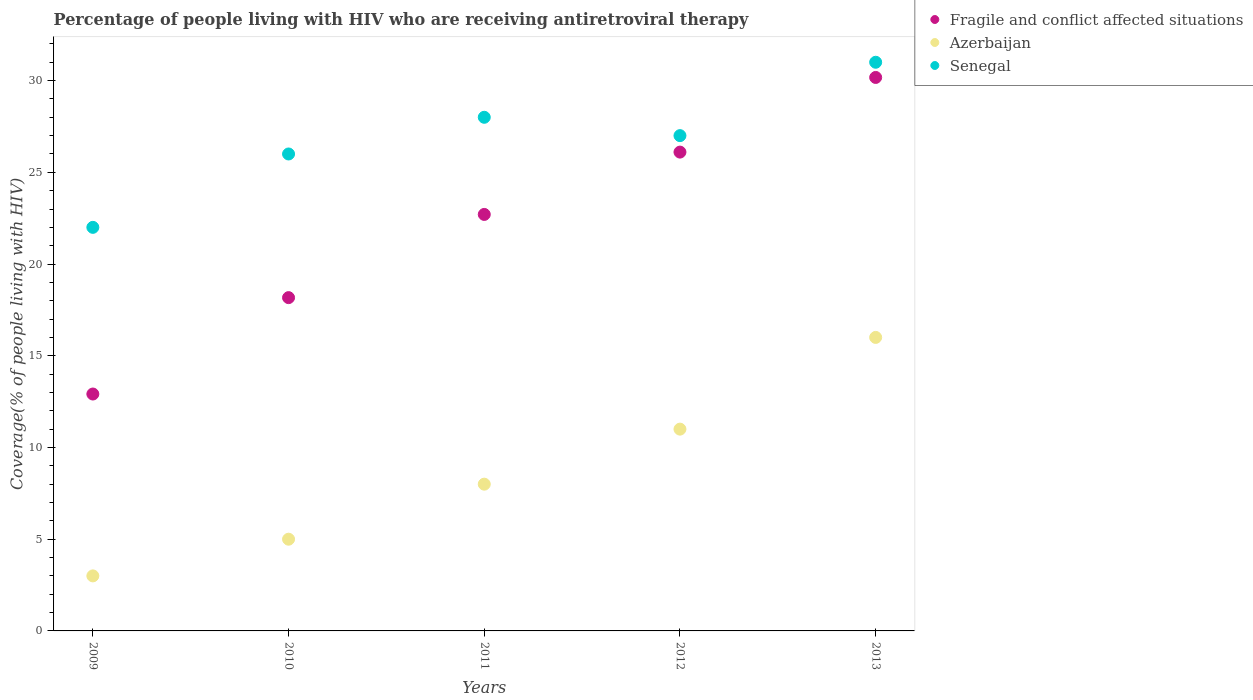How many different coloured dotlines are there?
Ensure brevity in your answer.  3. Is the number of dotlines equal to the number of legend labels?
Keep it short and to the point. Yes. What is the percentage of the HIV infected people who are receiving antiretroviral therapy in Fragile and conflict affected situations in 2012?
Give a very brief answer. 26.1. Across all years, what is the maximum percentage of the HIV infected people who are receiving antiretroviral therapy in Senegal?
Give a very brief answer. 31. Across all years, what is the minimum percentage of the HIV infected people who are receiving antiretroviral therapy in Azerbaijan?
Provide a succinct answer. 3. What is the total percentage of the HIV infected people who are receiving antiretroviral therapy in Azerbaijan in the graph?
Your answer should be compact. 43. What is the difference between the percentage of the HIV infected people who are receiving antiretroviral therapy in Azerbaijan in 2009 and that in 2013?
Offer a very short reply. -13. What is the difference between the percentage of the HIV infected people who are receiving antiretroviral therapy in Azerbaijan in 2013 and the percentage of the HIV infected people who are receiving antiretroviral therapy in Fragile and conflict affected situations in 2012?
Ensure brevity in your answer.  -10.1. What is the average percentage of the HIV infected people who are receiving antiretroviral therapy in Fragile and conflict affected situations per year?
Your answer should be very brief. 22.01. In the year 2010, what is the difference between the percentage of the HIV infected people who are receiving antiretroviral therapy in Azerbaijan and percentage of the HIV infected people who are receiving antiretroviral therapy in Senegal?
Provide a short and direct response. -21. In how many years, is the percentage of the HIV infected people who are receiving antiretroviral therapy in Azerbaijan greater than 18 %?
Provide a short and direct response. 0. What is the ratio of the percentage of the HIV infected people who are receiving antiretroviral therapy in Azerbaijan in 2009 to that in 2011?
Your answer should be compact. 0.38. What is the difference between the highest and the second highest percentage of the HIV infected people who are receiving antiretroviral therapy in Fragile and conflict affected situations?
Provide a succinct answer. 4.07. What is the difference between the highest and the lowest percentage of the HIV infected people who are receiving antiretroviral therapy in Fragile and conflict affected situations?
Make the answer very short. 17.26. Is the sum of the percentage of the HIV infected people who are receiving antiretroviral therapy in Fragile and conflict affected situations in 2009 and 2011 greater than the maximum percentage of the HIV infected people who are receiving antiretroviral therapy in Senegal across all years?
Offer a very short reply. Yes. Is it the case that in every year, the sum of the percentage of the HIV infected people who are receiving antiretroviral therapy in Fragile and conflict affected situations and percentage of the HIV infected people who are receiving antiretroviral therapy in Senegal  is greater than the percentage of the HIV infected people who are receiving antiretroviral therapy in Azerbaijan?
Offer a terse response. Yes. What is the difference between two consecutive major ticks on the Y-axis?
Ensure brevity in your answer.  5. Does the graph contain grids?
Your answer should be very brief. No. How are the legend labels stacked?
Make the answer very short. Vertical. What is the title of the graph?
Your response must be concise. Percentage of people living with HIV who are receiving antiretroviral therapy. What is the label or title of the X-axis?
Make the answer very short. Years. What is the label or title of the Y-axis?
Your response must be concise. Coverage(% of people living with HIV). What is the Coverage(% of people living with HIV) in Fragile and conflict affected situations in 2009?
Give a very brief answer. 12.91. What is the Coverage(% of people living with HIV) in Fragile and conflict affected situations in 2010?
Ensure brevity in your answer.  18.17. What is the Coverage(% of people living with HIV) of Azerbaijan in 2010?
Provide a succinct answer. 5. What is the Coverage(% of people living with HIV) in Senegal in 2010?
Give a very brief answer. 26. What is the Coverage(% of people living with HIV) in Fragile and conflict affected situations in 2011?
Ensure brevity in your answer.  22.7. What is the Coverage(% of people living with HIV) of Senegal in 2011?
Provide a short and direct response. 28. What is the Coverage(% of people living with HIV) of Fragile and conflict affected situations in 2012?
Give a very brief answer. 26.1. What is the Coverage(% of people living with HIV) of Fragile and conflict affected situations in 2013?
Keep it short and to the point. 30.17. What is the Coverage(% of people living with HIV) of Azerbaijan in 2013?
Provide a succinct answer. 16. Across all years, what is the maximum Coverage(% of people living with HIV) in Fragile and conflict affected situations?
Offer a terse response. 30.17. Across all years, what is the maximum Coverage(% of people living with HIV) in Azerbaijan?
Provide a succinct answer. 16. Across all years, what is the minimum Coverage(% of people living with HIV) in Fragile and conflict affected situations?
Your answer should be very brief. 12.91. What is the total Coverage(% of people living with HIV) in Fragile and conflict affected situations in the graph?
Your answer should be very brief. 110.06. What is the total Coverage(% of people living with HIV) of Senegal in the graph?
Your answer should be compact. 134. What is the difference between the Coverage(% of people living with HIV) in Fragile and conflict affected situations in 2009 and that in 2010?
Give a very brief answer. -5.25. What is the difference between the Coverage(% of people living with HIV) of Azerbaijan in 2009 and that in 2010?
Make the answer very short. -2. What is the difference between the Coverage(% of people living with HIV) of Fragile and conflict affected situations in 2009 and that in 2011?
Provide a short and direct response. -9.79. What is the difference between the Coverage(% of people living with HIV) in Azerbaijan in 2009 and that in 2011?
Ensure brevity in your answer.  -5. What is the difference between the Coverage(% of people living with HIV) in Fragile and conflict affected situations in 2009 and that in 2012?
Your answer should be compact. -13.19. What is the difference between the Coverage(% of people living with HIV) of Senegal in 2009 and that in 2012?
Make the answer very short. -5. What is the difference between the Coverage(% of people living with HIV) of Fragile and conflict affected situations in 2009 and that in 2013?
Offer a terse response. -17.26. What is the difference between the Coverage(% of people living with HIV) of Fragile and conflict affected situations in 2010 and that in 2011?
Offer a terse response. -4.54. What is the difference between the Coverage(% of people living with HIV) of Azerbaijan in 2010 and that in 2011?
Your answer should be very brief. -3. What is the difference between the Coverage(% of people living with HIV) of Senegal in 2010 and that in 2011?
Offer a very short reply. -2. What is the difference between the Coverage(% of people living with HIV) in Fragile and conflict affected situations in 2010 and that in 2012?
Provide a succinct answer. -7.93. What is the difference between the Coverage(% of people living with HIV) of Fragile and conflict affected situations in 2010 and that in 2013?
Provide a short and direct response. -12. What is the difference between the Coverage(% of people living with HIV) in Azerbaijan in 2010 and that in 2013?
Make the answer very short. -11. What is the difference between the Coverage(% of people living with HIV) of Fragile and conflict affected situations in 2011 and that in 2012?
Give a very brief answer. -3.4. What is the difference between the Coverage(% of people living with HIV) of Azerbaijan in 2011 and that in 2012?
Offer a terse response. -3. What is the difference between the Coverage(% of people living with HIV) of Senegal in 2011 and that in 2012?
Make the answer very short. 1. What is the difference between the Coverage(% of people living with HIV) in Fragile and conflict affected situations in 2011 and that in 2013?
Your answer should be compact. -7.47. What is the difference between the Coverage(% of people living with HIV) in Fragile and conflict affected situations in 2012 and that in 2013?
Offer a very short reply. -4.07. What is the difference between the Coverage(% of people living with HIV) of Azerbaijan in 2012 and that in 2013?
Your answer should be very brief. -5. What is the difference between the Coverage(% of people living with HIV) of Senegal in 2012 and that in 2013?
Offer a terse response. -4. What is the difference between the Coverage(% of people living with HIV) in Fragile and conflict affected situations in 2009 and the Coverage(% of people living with HIV) in Azerbaijan in 2010?
Provide a succinct answer. 7.91. What is the difference between the Coverage(% of people living with HIV) of Fragile and conflict affected situations in 2009 and the Coverage(% of people living with HIV) of Senegal in 2010?
Your answer should be very brief. -13.09. What is the difference between the Coverage(% of people living with HIV) of Fragile and conflict affected situations in 2009 and the Coverage(% of people living with HIV) of Azerbaijan in 2011?
Your answer should be very brief. 4.91. What is the difference between the Coverage(% of people living with HIV) in Fragile and conflict affected situations in 2009 and the Coverage(% of people living with HIV) in Senegal in 2011?
Keep it short and to the point. -15.09. What is the difference between the Coverage(% of people living with HIV) of Azerbaijan in 2009 and the Coverage(% of people living with HIV) of Senegal in 2011?
Your answer should be compact. -25. What is the difference between the Coverage(% of people living with HIV) of Fragile and conflict affected situations in 2009 and the Coverage(% of people living with HIV) of Azerbaijan in 2012?
Make the answer very short. 1.91. What is the difference between the Coverage(% of people living with HIV) of Fragile and conflict affected situations in 2009 and the Coverage(% of people living with HIV) of Senegal in 2012?
Keep it short and to the point. -14.09. What is the difference between the Coverage(% of people living with HIV) in Fragile and conflict affected situations in 2009 and the Coverage(% of people living with HIV) in Azerbaijan in 2013?
Give a very brief answer. -3.09. What is the difference between the Coverage(% of people living with HIV) of Fragile and conflict affected situations in 2009 and the Coverage(% of people living with HIV) of Senegal in 2013?
Keep it short and to the point. -18.09. What is the difference between the Coverage(% of people living with HIV) of Azerbaijan in 2009 and the Coverage(% of people living with HIV) of Senegal in 2013?
Your response must be concise. -28. What is the difference between the Coverage(% of people living with HIV) of Fragile and conflict affected situations in 2010 and the Coverage(% of people living with HIV) of Azerbaijan in 2011?
Make the answer very short. 10.17. What is the difference between the Coverage(% of people living with HIV) in Fragile and conflict affected situations in 2010 and the Coverage(% of people living with HIV) in Senegal in 2011?
Your answer should be very brief. -9.83. What is the difference between the Coverage(% of people living with HIV) in Fragile and conflict affected situations in 2010 and the Coverage(% of people living with HIV) in Azerbaijan in 2012?
Your answer should be very brief. 7.17. What is the difference between the Coverage(% of people living with HIV) of Fragile and conflict affected situations in 2010 and the Coverage(% of people living with HIV) of Senegal in 2012?
Make the answer very short. -8.83. What is the difference between the Coverage(% of people living with HIV) in Azerbaijan in 2010 and the Coverage(% of people living with HIV) in Senegal in 2012?
Provide a short and direct response. -22. What is the difference between the Coverage(% of people living with HIV) in Fragile and conflict affected situations in 2010 and the Coverage(% of people living with HIV) in Azerbaijan in 2013?
Provide a succinct answer. 2.17. What is the difference between the Coverage(% of people living with HIV) in Fragile and conflict affected situations in 2010 and the Coverage(% of people living with HIV) in Senegal in 2013?
Offer a terse response. -12.83. What is the difference between the Coverage(% of people living with HIV) in Azerbaijan in 2010 and the Coverage(% of people living with HIV) in Senegal in 2013?
Give a very brief answer. -26. What is the difference between the Coverage(% of people living with HIV) of Fragile and conflict affected situations in 2011 and the Coverage(% of people living with HIV) of Azerbaijan in 2012?
Keep it short and to the point. 11.7. What is the difference between the Coverage(% of people living with HIV) in Fragile and conflict affected situations in 2011 and the Coverage(% of people living with HIV) in Senegal in 2012?
Make the answer very short. -4.3. What is the difference between the Coverage(% of people living with HIV) in Azerbaijan in 2011 and the Coverage(% of people living with HIV) in Senegal in 2012?
Provide a succinct answer. -19. What is the difference between the Coverage(% of people living with HIV) in Fragile and conflict affected situations in 2011 and the Coverage(% of people living with HIV) in Azerbaijan in 2013?
Ensure brevity in your answer.  6.7. What is the difference between the Coverage(% of people living with HIV) in Fragile and conflict affected situations in 2011 and the Coverage(% of people living with HIV) in Senegal in 2013?
Ensure brevity in your answer.  -8.3. What is the difference between the Coverage(% of people living with HIV) of Fragile and conflict affected situations in 2012 and the Coverage(% of people living with HIV) of Azerbaijan in 2013?
Your answer should be very brief. 10.1. What is the difference between the Coverage(% of people living with HIV) of Fragile and conflict affected situations in 2012 and the Coverage(% of people living with HIV) of Senegal in 2013?
Your response must be concise. -4.9. What is the difference between the Coverage(% of people living with HIV) in Azerbaijan in 2012 and the Coverage(% of people living with HIV) in Senegal in 2013?
Ensure brevity in your answer.  -20. What is the average Coverage(% of people living with HIV) of Fragile and conflict affected situations per year?
Give a very brief answer. 22.01. What is the average Coverage(% of people living with HIV) of Senegal per year?
Your answer should be very brief. 26.8. In the year 2009, what is the difference between the Coverage(% of people living with HIV) in Fragile and conflict affected situations and Coverage(% of people living with HIV) in Azerbaijan?
Keep it short and to the point. 9.91. In the year 2009, what is the difference between the Coverage(% of people living with HIV) of Fragile and conflict affected situations and Coverage(% of people living with HIV) of Senegal?
Your response must be concise. -9.09. In the year 2009, what is the difference between the Coverage(% of people living with HIV) of Azerbaijan and Coverage(% of people living with HIV) of Senegal?
Your response must be concise. -19. In the year 2010, what is the difference between the Coverage(% of people living with HIV) in Fragile and conflict affected situations and Coverage(% of people living with HIV) in Azerbaijan?
Your answer should be very brief. 13.17. In the year 2010, what is the difference between the Coverage(% of people living with HIV) in Fragile and conflict affected situations and Coverage(% of people living with HIV) in Senegal?
Offer a very short reply. -7.83. In the year 2010, what is the difference between the Coverage(% of people living with HIV) of Azerbaijan and Coverage(% of people living with HIV) of Senegal?
Make the answer very short. -21. In the year 2011, what is the difference between the Coverage(% of people living with HIV) in Fragile and conflict affected situations and Coverage(% of people living with HIV) in Azerbaijan?
Make the answer very short. 14.7. In the year 2011, what is the difference between the Coverage(% of people living with HIV) in Fragile and conflict affected situations and Coverage(% of people living with HIV) in Senegal?
Keep it short and to the point. -5.3. In the year 2012, what is the difference between the Coverage(% of people living with HIV) in Fragile and conflict affected situations and Coverage(% of people living with HIV) in Azerbaijan?
Make the answer very short. 15.1. In the year 2012, what is the difference between the Coverage(% of people living with HIV) in Fragile and conflict affected situations and Coverage(% of people living with HIV) in Senegal?
Ensure brevity in your answer.  -0.9. In the year 2012, what is the difference between the Coverage(% of people living with HIV) of Azerbaijan and Coverage(% of people living with HIV) of Senegal?
Ensure brevity in your answer.  -16. In the year 2013, what is the difference between the Coverage(% of people living with HIV) in Fragile and conflict affected situations and Coverage(% of people living with HIV) in Azerbaijan?
Keep it short and to the point. 14.17. In the year 2013, what is the difference between the Coverage(% of people living with HIV) in Fragile and conflict affected situations and Coverage(% of people living with HIV) in Senegal?
Offer a very short reply. -0.83. What is the ratio of the Coverage(% of people living with HIV) in Fragile and conflict affected situations in 2009 to that in 2010?
Ensure brevity in your answer.  0.71. What is the ratio of the Coverage(% of people living with HIV) of Azerbaijan in 2009 to that in 2010?
Offer a terse response. 0.6. What is the ratio of the Coverage(% of people living with HIV) in Senegal in 2009 to that in 2010?
Offer a terse response. 0.85. What is the ratio of the Coverage(% of people living with HIV) in Fragile and conflict affected situations in 2009 to that in 2011?
Your response must be concise. 0.57. What is the ratio of the Coverage(% of people living with HIV) of Senegal in 2009 to that in 2011?
Make the answer very short. 0.79. What is the ratio of the Coverage(% of people living with HIV) in Fragile and conflict affected situations in 2009 to that in 2012?
Give a very brief answer. 0.49. What is the ratio of the Coverage(% of people living with HIV) of Azerbaijan in 2009 to that in 2012?
Provide a succinct answer. 0.27. What is the ratio of the Coverage(% of people living with HIV) of Senegal in 2009 to that in 2012?
Keep it short and to the point. 0.81. What is the ratio of the Coverage(% of people living with HIV) of Fragile and conflict affected situations in 2009 to that in 2013?
Keep it short and to the point. 0.43. What is the ratio of the Coverage(% of people living with HIV) in Azerbaijan in 2009 to that in 2013?
Keep it short and to the point. 0.19. What is the ratio of the Coverage(% of people living with HIV) in Senegal in 2009 to that in 2013?
Make the answer very short. 0.71. What is the ratio of the Coverage(% of people living with HIV) in Fragile and conflict affected situations in 2010 to that in 2011?
Ensure brevity in your answer.  0.8. What is the ratio of the Coverage(% of people living with HIV) of Senegal in 2010 to that in 2011?
Offer a terse response. 0.93. What is the ratio of the Coverage(% of people living with HIV) in Fragile and conflict affected situations in 2010 to that in 2012?
Offer a very short reply. 0.7. What is the ratio of the Coverage(% of people living with HIV) in Azerbaijan in 2010 to that in 2012?
Provide a succinct answer. 0.45. What is the ratio of the Coverage(% of people living with HIV) in Fragile and conflict affected situations in 2010 to that in 2013?
Keep it short and to the point. 0.6. What is the ratio of the Coverage(% of people living with HIV) in Azerbaijan in 2010 to that in 2013?
Provide a short and direct response. 0.31. What is the ratio of the Coverage(% of people living with HIV) of Senegal in 2010 to that in 2013?
Your answer should be very brief. 0.84. What is the ratio of the Coverage(% of people living with HIV) of Fragile and conflict affected situations in 2011 to that in 2012?
Keep it short and to the point. 0.87. What is the ratio of the Coverage(% of people living with HIV) of Azerbaijan in 2011 to that in 2012?
Your answer should be very brief. 0.73. What is the ratio of the Coverage(% of people living with HIV) of Senegal in 2011 to that in 2012?
Offer a terse response. 1.04. What is the ratio of the Coverage(% of people living with HIV) in Fragile and conflict affected situations in 2011 to that in 2013?
Keep it short and to the point. 0.75. What is the ratio of the Coverage(% of people living with HIV) in Azerbaijan in 2011 to that in 2013?
Offer a very short reply. 0.5. What is the ratio of the Coverage(% of people living with HIV) of Senegal in 2011 to that in 2013?
Your answer should be very brief. 0.9. What is the ratio of the Coverage(% of people living with HIV) of Fragile and conflict affected situations in 2012 to that in 2013?
Offer a very short reply. 0.87. What is the ratio of the Coverage(% of people living with HIV) of Azerbaijan in 2012 to that in 2013?
Your answer should be very brief. 0.69. What is the ratio of the Coverage(% of people living with HIV) of Senegal in 2012 to that in 2013?
Offer a terse response. 0.87. What is the difference between the highest and the second highest Coverage(% of people living with HIV) of Fragile and conflict affected situations?
Your response must be concise. 4.07. What is the difference between the highest and the second highest Coverage(% of people living with HIV) of Senegal?
Your answer should be very brief. 3. What is the difference between the highest and the lowest Coverage(% of people living with HIV) of Fragile and conflict affected situations?
Offer a terse response. 17.26. What is the difference between the highest and the lowest Coverage(% of people living with HIV) of Azerbaijan?
Provide a short and direct response. 13. 